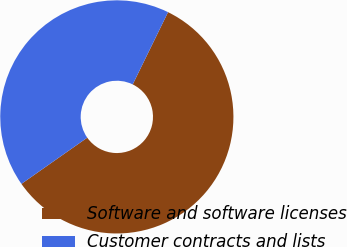<chart> <loc_0><loc_0><loc_500><loc_500><pie_chart><fcel>Software and software licenses<fcel>Customer contracts and lists<nl><fcel>58.02%<fcel>41.98%<nl></chart> 